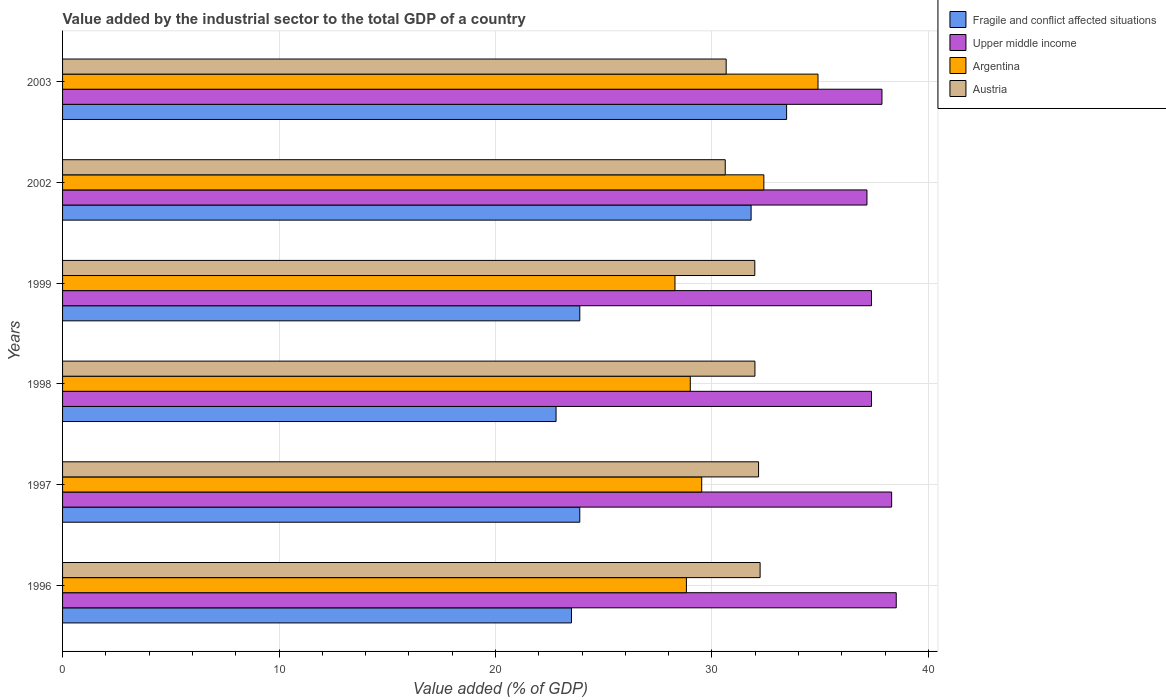How many groups of bars are there?
Offer a very short reply. 6. Are the number of bars per tick equal to the number of legend labels?
Your answer should be very brief. Yes. How many bars are there on the 4th tick from the top?
Give a very brief answer. 4. How many bars are there on the 2nd tick from the bottom?
Your answer should be very brief. 4. In how many cases, is the number of bars for a given year not equal to the number of legend labels?
Give a very brief answer. 0. What is the value added by the industrial sector to the total GDP in Austria in 1996?
Offer a terse response. 32.23. Across all years, what is the maximum value added by the industrial sector to the total GDP in Upper middle income?
Your answer should be compact. 38.52. Across all years, what is the minimum value added by the industrial sector to the total GDP in Austria?
Provide a short and direct response. 30.62. In which year was the value added by the industrial sector to the total GDP in Austria maximum?
Your response must be concise. 1996. In which year was the value added by the industrial sector to the total GDP in Argentina minimum?
Your answer should be very brief. 1999. What is the total value added by the industrial sector to the total GDP in Fragile and conflict affected situations in the graph?
Give a very brief answer. 159.37. What is the difference between the value added by the industrial sector to the total GDP in Fragile and conflict affected situations in 1997 and that in 2003?
Provide a succinct answer. -9.56. What is the difference between the value added by the industrial sector to the total GDP in Upper middle income in 1996 and the value added by the industrial sector to the total GDP in Austria in 1999?
Make the answer very short. 6.54. What is the average value added by the industrial sector to the total GDP in Austria per year?
Your answer should be very brief. 31.6. In the year 2003, what is the difference between the value added by the industrial sector to the total GDP in Fragile and conflict affected situations and value added by the industrial sector to the total GDP in Argentina?
Keep it short and to the point. -1.45. What is the ratio of the value added by the industrial sector to the total GDP in Upper middle income in 1997 to that in 1998?
Provide a succinct answer. 1.02. Is the value added by the industrial sector to the total GDP in Argentina in 1997 less than that in 1998?
Your response must be concise. No. What is the difference between the highest and the second highest value added by the industrial sector to the total GDP in Upper middle income?
Keep it short and to the point. 0.21. What is the difference between the highest and the lowest value added by the industrial sector to the total GDP in Fragile and conflict affected situations?
Provide a succinct answer. 10.65. In how many years, is the value added by the industrial sector to the total GDP in Fragile and conflict affected situations greater than the average value added by the industrial sector to the total GDP in Fragile and conflict affected situations taken over all years?
Your response must be concise. 2. Is the sum of the value added by the industrial sector to the total GDP in Fragile and conflict affected situations in 1997 and 2002 greater than the maximum value added by the industrial sector to the total GDP in Upper middle income across all years?
Provide a succinct answer. Yes. Is it the case that in every year, the sum of the value added by the industrial sector to the total GDP in Fragile and conflict affected situations and value added by the industrial sector to the total GDP in Austria is greater than the sum of value added by the industrial sector to the total GDP in Argentina and value added by the industrial sector to the total GDP in Upper middle income?
Ensure brevity in your answer.  No. What does the 3rd bar from the top in 1996 represents?
Your answer should be very brief. Upper middle income. Is it the case that in every year, the sum of the value added by the industrial sector to the total GDP in Fragile and conflict affected situations and value added by the industrial sector to the total GDP in Austria is greater than the value added by the industrial sector to the total GDP in Argentina?
Provide a succinct answer. Yes. How many bars are there?
Your answer should be very brief. 24. Are all the bars in the graph horizontal?
Provide a short and direct response. Yes. What is the difference between two consecutive major ticks on the X-axis?
Your answer should be very brief. 10. How many legend labels are there?
Your answer should be very brief. 4. What is the title of the graph?
Offer a very short reply. Value added by the industrial sector to the total GDP of a country. What is the label or title of the X-axis?
Your answer should be very brief. Value added (% of GDP). What is the Value added (% of GDP) in Fragile and conflict affected situations in 1996?
Your answer should be compact. 23.51. What is the Value added (% of GDP) in Upper middle income in 1996?
Offer a very short reply. 38.52. What is the Value added (% of GDP) in Argentina in 1996?
Keep it short and to the point. 28.82. What is the Value added (% of GDP) in Austria in 1996?
Your answer should be very brief. 32.23. What is the Value added (% of GDP) in Fragile and conflict affected situations in 1997?
Provide a short and direct response. 23.9. What is the Value added (% of GDP) in Upper middle income in 1997?
Ensure brevity in your answer.  38.3. What is the Value added (% of GDP) in Argentina in 1997?
Give a very brief answer. 29.53. What is the Value added (% of GDP) of Austria in 1997?
Provide a short and direct response. 32.16. What is the Value added (% of GDP) of Fragile and conflict affected situations in 1998?
Offer a very short reply. 22.8. What is the Value added (% of GDP) of Upper middle income in 1998?
Keep it short and to the point. 37.37. What is the Value added (% of GDP) of Argentina in 1998?
Ensure brevity in your answer.  29. What is the Value added (% of GDP) of Austria in 1998?
Keep it short and to the point. 31.99. What is the Value added (% of GDP) in Fragile and conflict affected situations in 1999?
Offer a terse response. 23.9. What is the Value added (% of GDP) of Upper middle income in 1999?
Make the answer very short. 37.37. What is the Value added (% of GDP) of Argentina in 1999?
Provide a short and direct response. 28.29. What is the Value added (% of GDP) of Austria in 1999?
Make the answer very short. 31.98. What is the Value added (% of GDP) in Fragile and conflict affected situations in 2002?
Offer a terse response. 31.81. What is the Value added (% of GDP) of Upper middle income in 2002?
Your answer should be compact. 37.16. What is the Value added (% of GDP) in Argentina in 2002?
Your answer should be very brief. 32.4. What is the Value added (% of GDP) in Austria in 2002?
Your answer should be compact. 30.62. What is the Value added (% of GDP) of Fragile and conflict affected situations in 2003?
Your answer should be very brief. 33.45. What is the Value added (% of GDP) of Upper middle income in 2003?
Give a very brief answer. 37.86. What is the Value added (% of GDP) of Argentina in 2003?
Your response must be concise. 34.9. What is the Value added (% of GDP) in Austria in 2003?
Your answer should be very brief. 30.66. Across all years, what is the maximum Value added (% of GDP) in Fragile and conflict affected situations?
Make the answer very short. 33.45. Across all years, what is the maximum Value added (% of GDP) in Upper middle income?
Offer a very short reply. 38.52. Across all years, what is the maximum Value added (% of GDP) in Argentina?
Your answer should be very brief. 34.9. Across all years, what is the maximum Value added (% of GDP) in Austria?
Make the answer very short. 32.23. Across all years, what is the minimum Value added (% of GDP) in Fragile and conflict affected situations?
Your answer should be very brief. 22.8. Across all years, what is the minimum Value added (% of GDP) in Upper middle income?
Offer a terse response. 37.16. Across all years, what is the minimum Value added (% of GDP) of Argentina?
Provide a short and direct response. 28.29. Across all years, what is the minimum Value added (% of GDP) in Austria?
Your answer should be compact. 30.62. What is the total Value added (% of GDP) of Fragile and conflict affected situations in the graph?
Your answer should be very brief. 159.37. What is the total Value added (% of GDP) in Upper middle income in the graph?
Make the answer very short. 226.59. What is the total Value added (% of GDP) in Argentina in the graph?
Make the answer very short. 182.95. What is the total Value added (% of GDP) of Austria in the graph?
Offer a very short reply. 189.63. What is the difference between the Value added (% of GDP) of Fragile and conflict affected situations in 1996 and that in 1997?
Offer a terse response. -0.38. What is the difference between the Value added (% of GDP) of Upper middle income in 1996 and that in 1997?
Your response must be concise. 0.21. What is the difference between the Value added (% of GDP) in Argentina in 1996 and that in 1997?
Give a very brief answer. -0.71. What is the difference between the Value added (% of GDP) in Austria in 1996 and that in 1997?
Offer a very short reply. 0.07. What is the difference between the Value added (% of GDP) of Fragile and conflict affected situations in 1996 and that in 1998?
Your response must be concise. 0.71. What is the difference between the Value added (% of GDP) of Upper middle income in 1996 and that in 1998?
Offer a terse response. 1.14. What is the difference between the Value added (% of GDP) in Argentina in 1996 and that in 1998?
Your answer should be very brief. -0.18. What is the difference between the Value added (% of GDP) in Austria in 1996 and that in 1998?
Offer a very short reply. 0.24. What is the difference between the Value added (% of GDP) of Fragile and conflict affected situations in 1996 and that in 1999?
Provide a succinct answer. -0.39. What is the difference between the Value added (% of GDP) in Upper middle income in 1996 and that in 1999?
Your answer should be compact. 1.14. What is the difference between the Value added (% of GDP) of Argentina in 1996 and that in 1999?
Provide a succinct answer. 0.53. What is the difference between the Value added (% of GDP) in Austria in 1996 and that in 1999?
Make the answer very short. 0.25. What is the difference between the Value added (% of GDP) of Fragile and conflict affected situations in 1996 and that in 2002?
Keep it short and to the point. -8.3. What is the difference between the Value added (% of GDP) of Upper middle income in 1996 and that in 2002?
Offer a very short reply. 1.35. What is the difference between the Value added (% of GDP) of Argentina in 1996 and that in 2002?
Offer a very short reply. -3.58. What is the difference between the Value added (% of GDP) of Austria in 1996 and that in 2002?
Ensure brevity in your answer.  1.61. What is the difference between the Value added (% of GDP) in Fragile and conflict affected situations in 1996 and that in 2003?
Your answer should be very brief. -9.94. What is the difference between the Value added (% of GDP) of Upper middle income in 1996 and that in 2003?
Give a very brief answer. 0.66. What is the difference between the Value added (% of GDP) in Argentina in 1996 and that in 2003?
Your answer should be compact. -6.08. What is the difference between the Value added (% of GDP) of Austria in 1996 and that in 2003?
Your answer should be compact. 1.57. What is the difference between the Value added (% of GDP) in Fragile and conflict affected situations in 1997 and that in 1998?
Keep it short and to the point. 1.1. What is the difference between the Value added (% of GDP) in Upper middle income in 1997 and that in 1998?
Keep it short and to the point. 0.93. What is the difference between the Value added (% of GDP) in Argentina in 1997 and that in 1998?
Ensure brevity in your answer.  0.53. What is the difference between the Value added (% of GDP) of Austria in 1997 and that in 1998?
Offer a terse response. 0.17. What is the difference between the Value added (% of GDP) of Fragile and conflict affected situations in 1997 and that in 1999?
Your answer should be very brief. -0. What is the difference between the Value added (% of GDP) in Upper middle income in 1997 and that in 1999?
Make the answer very short. 0.93. What is the difference between the Value added (% of GDP) in Argentina in 1997 and that in 1999?
Your answer should be very brief. 1.23. What is the difference between the Value added (% of GDP) of Austria in 1997 and that in 1999?
Keep it short and to the point. 0.17. What is the difference between the Value added (% of GDP) of Fragile and conflict affected situations in 1997 and that in 2002?
Ensure brevity in your answer.  -7.92. What is the difference between the Value added (% of GDP) in Upper middle income in 1997 and that in 2002?
Your answer should be compact. 1.14. What is the difference between the Value added (% of GDP) of Argentina in 1997 and that in 2002?
Provide a short and direct response. -2.87. What is the difference between the Value added (% of GDP) in Austria in 1997 and that in 2002?
Keep it short and to the point. 1.54. What is the difference between the Value added (% of GDP) of Fragile and conflict affected situations in 1997 and that in 2003?
Keep it short and to the point. -9.56. What is the difference between the Value added (% of GDP) in Upper middle income in 1997 and that in 2003?
Provide a succinct answer. 0.45. What is the difference between the Value added (% of GDP) of Argentina in 1997 and that in 2003?
Offer a terse response. -5.37. What is the difference between the Value added (% of GDP) of Austria in 1997 and that in 2003?
Your answer should be compact. 1.5. What is the difference between the Value added (% of GDP) in Fragile and conflict affected situations in 1998 and that in 1999?
Offer a very short reply. -1.1. What is the difference between the Value added (% of GDP) in Upper middle income in 1998 and that in 1999?
Ensure brevity in your answer.  -0. What is the difference between the Value added (% of GDP) in Argentina in 1998 and that in 1999?
Give a very brief answer. 0.71. What is the difference between the Value added (% of GDP) in Austria in 1998 and that in 1999?
Your response must be concise. 0.01. What is the difference between the Value added (% of GDP) of Fragile and conflict affected situations in 1998 and that in 2002?
Offer a very short reply. -9.01. What is the difference between the Value added (% of GDP) of Upper middle income in 1998 and that in 2002?
Give a very brief answer. 0.21. What is the difference between the Value added (% of GDP) of Argentina in 1998 and that in 2002?
Give a very brief answer. -3.4. What is the difference between the Value added (% of GDP) in Austria in 1998 and that in 2002?
Your response must be concise. 1.37. What is the difference between the Value added (% of GDP) of Fragile and conflict affected situations in 1998 and that in 2003?
Provide a short and direct response. -10.65. What is the difference between the Value added (% of GDP) in Upper middle income in 1998 and that in 2003?
Keep it short and to the point. -0.48. What is the difference between the Value added (% of GDP) of Argentina in 1998 and that in 2003?
Offer a terse response. -5.9. What is the difference between the Value added (% of GDP) in Austria in 1998 and that in 2003?
Provide a succinct answer. 1.33. What is the difference between the Value added (% of GDP) of Fragile and conflict affected situations in 1999 and that in 2002?
Offer a terse response. -7.91. What is the difference between the Value added (% of GDP) of Upper middle income in 1999 and that in 2002?
Ensure brevity in your answer.  0.21. What is the difference between the Value added (% of GDP) in Argentina in 1999 and that in 2002?
Ensure brevity in your answer.  -4.11. What is the difference between the Value added (% of GDP) of Austria in 1999 and that in 2002?
Provide a short and direct response. 1.37. What is the difference between the Value added (% of GDP) in Fragile and conflict affected situations in 1999 and that in 2003?
Keep it short and to the point. -9.55. What is the difference between the Value added (% of GDP) in Upper middle income in 1999 and that in 2003?
Your answer should be compact. -0.48. What is the difference between the Value added (% of GDP) of Argentina in 1999 and that in 2003?
Your answer should be very brief. -6.61. What is the difference between the Value added (% of GDP) of Austria in 1999 and that in 2003?
Offer a terse response. 1.32. What is the difference between the Value added (% of GDP) in Fragile and conflict affected situations in 2002 and that in 2003?
Provide a short and direct response. -1.64. What is the difference between the Value added (% of GDP) of Upper middle income in 2002 and that in 2003?
Offer a terse response. -0.69. What is the difference between the Value added (% of GDP) of Argentina in 2002 and that in 2003?
Provide a short and direct response. -2.5. What is the difference between the Value added (% of GDP) of Austria in 2002 and that in 2003?
Ensure brevity in your answer.  -0.04. What is the difference between the Value added (% of GDP) of Fragile and conflict affected situations in 1996 and the Value added (% of GDP) of Upper middle income in 1997?
Make the answer very short. -14.79. What is the difference between the Value added (% of GDP) in Fragile and conflict affected situations in 1996 and the Value added (% of GDP) in Argentina in 1997?
Your response must be concise. -6.02. What is the difference between the Value added (% of GDP) in Fragile and conflict affected situations in 1996 and the Value added (% of GDP) in Austria in 1997?
Your response must be concise. -8.64. What is the difference between the Value added (% of GDP) in Upper middle income in 1996 and the Value added (% of GDP) in Argentina in 1997?
Provide a succinct answer. 8.99. What is the difference between the Value added (% of GDP) of Upper middle income in 1996 and the Value added (% of GDP) of Austria in 1997?
Offer a very short reply. 6.36. What is the difference between the Value added (% of GDP) in Argentina in 1996 and the Value added (% of GDP) in Austria in 1997?
Keep it short and to the point. -3.33. What is the difference between the Value added (% of GDP) of Fragile and conflict affected situations in 1996 and the Value added (% of GDP) of Upper middle income in 1998?
Provide a succinct answer. -13.86. What is the difference between the Value added (% of GDP) in Fragile and conflict affected situations in 1996 and the Value added (% of GDP) in Argentina in 1998?
Your response must be concise. -5.49. What is the difference between the Value added (% of GDP) in Fragile and conflict affected situations in 1996 and the Value added (% of GDP) in Austria in 1998?
Offer a terse response. -8.48. What is the difference between the Value added (% of GDP) in Upper middle income in 1996 and the Value added (% of GDP) in Argentina in 1998?
Provide a succinct answer. 9.52. What is the difference between the Value added (% of GDP) in Upper middle income in 1996 and the Value added (% of GDP) in Austria in 1998?
Offer a terse response. 6.53. What is the difference between the Value added (% of GDP) of Argentina in 1996 and the Value added (% of GDP) of Austria in 1998?
Make the answer very short. -3.17. What is the difference between the Value added (% of GDP) in Fragile and conflict affected situations in 1996 and the Value added (% of GDP) in Upper middle income in 1999?
Your answer should be compact. -13.86. What is the difference between the Value added (% of GDP) of Fragile and conflict affected situations in 1996 and the Value added (% of GDP) of Argentina in 1999?
Offer a terse response. -4.78. What is the difference between the Value added (% of GDP) in Fragile and conflict affected situations in 1996 and the Value added (% of GDP) in Austria in 1999?
Give a very brief answer. -8.47. What is the difference between the Value added (% of GDP) in Upper middle income in 1996 and the Value added (% of GDP) in Argentina in 1999?
Your answer should be very brief. 10.22. What is the difference between the Value added (% of GDP) of Upper middle income in 1996 and the Value added (% of GDP) of Austria in 1999?
Make the answer very short. 6.54. What is the difference between the Value added (% of GDP) in Argentina in 1996 and the Value added (% of GDP) in Austria in 1999?
Provide a succinct answer. -3.16. What is the difference between the Value added (% of GDP) of Fragile and conflict affected situations in 1996 and the Value added (% of GDP) of Upper middle income in 2002?
Make the answer very short. -13.65. What is the difference between the Value added (% of GDP) of Fragile and conflict affected situations in 1996 and the Value added (% of GDP) of Argentina in 2002?
Your answer should be compact. -8.89. What is the difference between the Value added (% of GDP) of Fragile and conflict affected situations in 1996 and the Value added (% of GDP) of Austria in 2002?
Your response must be concise. -7.1. What is the difference between the Value added (% of GDP) of Upper middle income in 1996 and the Value added (% of GDP) of Argentina in 2002?
Give a very brief answer. 6.12. What is the difference between the Value added (% of GDP) in Upper middle income in 1996 and the Value added (% of GDP) in Austria in 2002?
Keep it short and to the point. 7.9. What is the difference between the Value added (% of GDP) of Argentina in 1996 and the Value added (% of GDP) of Austria in 2002?
Your answer should be very brief. -1.79. What is the difference between the Value added (% of GDP) of Fragile and conflict affected situations in 1996 and the Value added (% of GDP) of Upper middle income in 2003?
Your response must be concise. -14.35. What is the difference between the Value added (% of GDP) of Fragile and conflict affected situations in 1996 and the Value added (% of GDP) of Argentina in 2003?
Ensure brevity in your answer.  -11.39. What is the difference between the Value added (% of GDP) of Fragile and conflict affected situations in 1996 and the Value added (% of GDP) of Austria in 2003?
Offer a very short reply. -7.15. What is the difference between the Value added (% of GDP) of Upper middle income in 1996 and the Value added (% of GDP) of Argentina in 2003?
Make the answer very short. 3.61. What is the difference between the Value added (% of GDP) in Upper middle income in 1996 and the Value added (% of GDP) in Austria in 2003?
Provide a short and direct response. 7.86. What is the difference between the Value added (% of GDP) of Argentina in 1996 and the Value added (% of GDP) of Austria in 2003?
Offer a very short reply. -1.84. What is the difference between the Value added (% of GDP) in Fragile and conflict affected situations in 1997 and the Value added (% of GDP) in Upper middle income in 1998?
Provide a succinct answer. -13.48. What is the difference between the Value added (% of GDP) in Fragile and conflict affected situations in 1997 and the Value added (% of GDP) in Argentina in 1998?
Provide a short and direct response. -5.11. What is the difference between the Value added (% of GDP) of Fragile and conflict affected situations in 1997 and the Value added (% of GDP) of Austria in 1998?
Your answer should be very brief. -8.09. What is the difference between the Value added (% of GDP) of Upper middle income in 1997 and the Value added (% of GDP) of Argentina in 1998?
Keep it short and to the point. 9.3. What is the difference between the Value added (% of GDP) in Upper middle income in 1997 and the Value added (% of GDP) in Austria in 1998?
Your answer should be very brief. 6.32. What is the difference between the Value added (% of GDP) of Argentina in 1997 and the Value added (% of GDP) of Austria in 1998?
Your answer should be very brief. -2.46. What is the difference between the Value added (% of GDP) in Fragile and conflict affected situations in 1997 and the Value added (% of GDP) in Upper middle income in 1999?
Give a very brief answer. -13.48. What is the difference between the Value added (% of GDP) in Fragile and conflict affected situations in 1997 and the Value added (% of GDP) in Argentina in 1999?
Keep it short and to the point. -4.4. What is the difference between the Value added (% of GDP) of Fragile and conflict affected situations in 1997 and the Value added (% of GDP) of Austria in 1999?
Your response must be concise. -8.09. What is the difference between the Value added (% of GDP) in Upper middle income in 1997 and the Value added (% of GDP) in Argentina in 1999?
Make the answer very short. 10.01. What is the difference between the Value added (% of GDP) of Upper middle income in 1997 and the Value added (% of GDP) of Austria in 1999?
Offer a terse response. 6.32. What is the difference between the Value added (% of GDP) in Argentina in 1997 and the Value added (% of GDP) in Austria in 1999?
Provide a short and direct response. -2.45. What is the difference between the Value added (% of GDP) in Fragile and conflict affected situations in 1997 and the Value added (% of GDP) in Upper middle income in 2002?
Provide a short and direct response. -13.27. What is the difference between the Value added (% of GDP) in Fragile and conflict affected situations in 1997 and the Value added (% of GDP) in Argentina in 2002?
Your response must be concise. -8.5. What is the difference between the Value added (% of GDP) of Fragile and conflict affected situations in 1997 and the Value added (% of GDP) of Austria in 2002?
Your answer should be compact. -6.72. What is the difference between the Value added (% of GDP) of Upper middle income in 1997 and the Value added (% of GDP) of Argentina in 2002?
Make the answer very short. 5.9. What is the difference between the Value added (% of GDP) of Upper middle income in 1997 and the Value added (% of GDP) of Austria in 2002?
Your answer should be compact. 7.69. What is the difference between the Value added (% of GDP) of Argentina in 1997 and the Value added (% of GDP) of Austria in 2002?
Keep it short and to the point. -1.09. What is the difference between the Value added (% of GDP) of Fragile and conflict affected situations in 1997 and the Value added (% of GDP) of Upper middle income in 2003?
Your answer should be compact. -13.96. What is the difference between the Value added (% of GDP) of Fragile and conflict affected situations in 1997 and the Value added (% of GDP) of Argentina in 2003?
Ensure brevity in your answer.  -11.01. What is the difference between the Value added (% of GDP) in Fragile and conflict affected situations in 1997 and the Value added (% of GDP) in Austria in 2003?
Offer a very short reply. -6.76. What is the difference between the Value added (% of GDP) of Upper middle income in 1997 and the Value added (% of GDP) of Argentina in 2003?
Offer a very short reply. 3.4. What is the difference between the Value added (% of GDP) of Upper middle income in 1997 and the Value added (% of GDP) of Austria in 2003?
Offer a terse response. 7.64. What is the difference between the Value added (% of GDP) in Argentina in 1997 and the Value added (% of GDP) in Austria in 2003?
Give a very brief answer. -1.13. What is the difference between the Value added (% of GDP) of Fragile and conflict affected situations in 1998 and the Value added (% of GDP) of Upper middle income in 1999?
Your answer should be compact. -14.57. What is the difference between the Value added (% of GDP) in Fragile and conflict affected situations in 1998 and the Value added (% of GDP) in Argentina in 1999?
Your answer should be compact. -5.49. What is the difference between the Value added (% of GDP) of Fragile and conflict affected situations in 1998 and the Value added (% of GDP) of Austria in 1999?
Provide a short and direct response. -9.18. What is the difference between the Value added (% of GDP) in Upper middle income in 1998 and the Value added (% of GDP) in Argentina in 1999?
Your answer should be compact. 9.08. What is the difference between the Value added (% of GDP) of Upper middle income in 1998 and the Value added (% of GDP) of Austria in 1999?
Offer a very short reply. 5.39. What is the difference between the Value added (% of GDP) in Argentina in 1998 and the Value added (% of GDP) in Austria in 1999?
Your answer should be compact. -2.98. What is the difference between the Value added (% of GDP) in Fragile and conflict affected situations in 1998 and the Value added (% of GDP) in Upper middle income in 2002?
Provide a short and direct response. -14.36. What is the difference between the Value added (% of GDP) in Fragile and conflict affected situations in 1998 and the Value added (% of GDP) in Argentina in 2002?
Your answer should be compact. -9.6. What is the difference between the Value added (% of GDP) of Fragile and conflict affected situations in 1998 and the Value added (% of GDP) of Austria in 2002?
Give a very brief answer. -7.82. What is the difference between the Value added (% of GDP) of Upper middle income in 1998 and the Value added (% of GDP) of Argentina in 2002?
Keep it short and to the point. 4.97. What is the difference between the Value added (% of GDP) of Upper middle income in 1998 and the Value added (% of GDP) of Austria in 2002?
Your answer should be very brief. 6.76. What is the difference between the Value added (% of GDP) in Argentina in 1998 and the Value added (% of GDP) in Austria in 2002?
Ensure brevity in your answer.  -1.61. What is the difference between the Value added (% of GDP) of Fragile and conflict affected situations in 1998 and the Value added (% of GDP) of Upper middle income in 2003?
Give a very brief answer. -15.06. What is the difference between the Value added (% of GDP) in Fragile and conflict affected situations in 1998 and the Value added (% of GDP) in Argentina in 2003?
Provide a short and direct response. -12.1. What is the difference between the Value added (% of GDP) in Fragile and conflict affected situations in 1998 and the Value added (% of GDP) in Austria in 2003?
Make the answer very short. -7.86. What is the difference between the Value added (% of GDP) in Upper middle income in 1998 and the Value added (% of GDP) in Argentina in 2003?
Make the answer very short. 2.47. What is the difference between the Value added (% of GDP) of Upper middle income in 1998 and the Value added (% of GDP) of Austria in 2003?
Provide a short and direct response. 6.71. What is the difference between the Value added (% of GDP) of Argentina in 1998 and the Value added (% of GDP) of Austria in 2003?
Make the answer very short. -1.66. What is the difference between the Value added (% of GDP) of Fragile and conflict affected situations in 1999 and the Value added (% of GDP) of Upper middle income in 2002?
Your response must be concise. -13.27. What is the difference between the Value added (% of GDP) of Fragile and conflict affected situations in 1999 and the Value added (% of GDP) of Argentina in 2002?
Your answer should be compact. -8.5. What is the difference between the Value added (% of GDP) in Fragile and conflict affected situations in 1999 and the Value added (% of GDP) in Austria in 2002?
Offer a very short reply. -6.72. What is the difference between the Value added (% of GDP) in Upper middle income in 1999 and the Value added (% of GDP) in Argentina in 2002?
Offer a very short reply. 4.97. What is the difference between the Value added (% of GDP) of Upper middle income in 1999 and the Value added (% of GDP) of Austria in 2002?
Your answer should be very brief. 6.76. What is the difference between the Value added (% of GDP) in Argentina in 1999 and the Value added (% of GDP) in Austria in 2002?
Your answer should be compact. -2.32. What is the difference between the Value added (% of GDP) in Fragile and conflict affected situations in 1999 and the Value added (% of GDP) in Upper middle income in 2003?
Offer a very short reply. -13.96. What is the difference between the Value added (% of GDP) of Fragile and conflict affected situations in 1999 and the Value added (% of GDP) of Argentina in 2003?
Offer a very short reply. -11.01. What is the difference between the Value added (% of GDP) in Fragile and conflict affected situations in 1999 and the Value added (% of GDP) in Austria in 2003?
Offer a very short reply. -6.76. What is the difference between the Value added (% of GDP) of Upper middle income in 1999 and the Value added (% of GDP) of Argentina in 2003?
Provide a short and direct response. 2.47. What is the difference between the Value added (% of GDP) in Upper middle income in 1999 and the Value added (% of GDP) in Austria in 2003?
Give a very brief answer. 6.71. What is the difference between the Value added (% of GDP) in Argentina in 1999 and the Value added (% of GDP) in Austria in 2003?
Ensure brevity in your answer.  -2.37. What is the difference between the Value added (% of GDP) in Fragile and conflict affected situations in 2002 and the Value added (% of GDP) in Upper middle income in 2003?
Your response must be concise. -6.05. What is the difference between the Value added (% of GDP) of Fragile and conflict affected situations in 2002 and the Value added (% of GDP) of Argentina in 2003?
Give a very brief answer. -3.09. What is the difference between the Value added (% of GDP) in Fragile and conflict affected situations in 2002 and the Value added (% of GDP) in Austria in 2003?
Your answer should be very brief. 1.15. What is the difference between the Value added (% of GDP) of Upper middle income in 2002 and the Value added (% of GDP) of Argentina in 2003?
Provide a succinct answer. 2.26. What is the difference between the Value added (% of GDP) of Upper middle income in 2002 and the Value added (% of GDP) of Austria in 2003?
Ensure brevity in your answer.  6.5. What is the difference between the Value added (% of GDP) of Argentina in 2002 and the Value added (% of GDP) of Austria in 2003?
Ensure brevity in your answer.  1.74. What is the average Value added (% of GDP) in Fragile and conflict affected situations per year?
Keep it short and to the point. 26.56. What is the average Value added (% of GDP) in Upper middle income per year?
Provide a short and direct response. 37.76. What is the average Value added (% of GDP) in Argentina per year?
Ensure brevity in your answer.  30.49. What is the average Value added (% of GDP) in Austria per year?
Your answer should be very brief. 31.6. In the year 1996, what is the difference between the Value added (% of GDP) in Fragile and conflict affected situations and Value added (% of GDP) in Upper middle income?
Your answer should be compact. -15.01. In the year 1996, what is the difference between the Value added (% of GDP) in Fragile and conflict affected situations and Value added (% of GDP) in Argentina?
Your answer should be compact. -5.31. In the year 1996, what is the difference between the Value added (% of GDP) of Fragile and conflict affected situations and Value added (% of GDP) of Austria?
Your answer should be compact. -8.72. In the year 1996, what is the difference between the Value added (% of GDP) of Upper middle income and Value added (% of GDP) of Argentina?
Your response must be concise. 9.7. In the year 1996, what is the difference between the Value added (% of GDP) in Upper middle income and Value added (% of GDP) in Austria?
Keep it short and to the point. 6.29. In the year 1996, what is the difference between the Value added (% of GDP) in Argentina and Value added (% of GDP) in Austria?
Offer a terse response. -3.41. In the year 1997, what is the difference between the Value added (% of GDP) in Fragile and conflict affected situations and Value added (% of GDP) in Upper middle income?
Offer a very short reply. -14.41. In the year 1997, what is the difference between the Value added (% of GDP) of Fragile and conflict affected situations and Value added (% of GDP) of Argentina?
Offer a very short reply. -5.63. In the year 1997, what is the difference between the Value added (% of GDP) in Fragile and conflict affected situations and Value added (% of GDP) in Austria?
Your answer should be compact. -8.26. In the year 1997, what is the difference between the Value added (% of GDP) of Upper middle income and Value added (% of GDP) of Argentina?
Provide a succinct answer. 8.78. In the year 1997, what is the difference between the Value added (% of GDP) of Upper middle income and Value added (% of GDP) of Austria?
Keep it short and to the point. 6.15. In the year 1997, what is the difference between the Value added (% of GDP) in Argentina and Value added (% of GDP) in Austria?
Offer a terse response. -2.63. In the year 1998, what is the difference between the Value added (% of GDP) of Fragile and conflict affected situations and Value added (% of GDP) of Upper middle income?
Provide a short and direct response. -14.57. In the year 1998, what is the difference between the Value added (% of GDP) in Fragile and conflict affected situations and Value added (% of GDP) in Argentina?
Make the answer very short. -6.2. In the year 1998, what is the difference between the Value added (% of GDP) of Fragile and conflict affected situations and Value added (% of GDP) of Austria?
Provide a succinct answer. -9.19. In the year 1998, what is the difference between the Value added (% of GDP) of Upper middle income and Value added (% of GDP) of Argentina?
Your response must be concise. 8.37. In the year 1998, what is the difference between the Value added (% of GDP) of Upper middle income and Value added (% of GDP) of Austria?
Your answer should be compact. 5.38. In the year 1998, what is the difference between the Value added (% of GDP) in Argentina and Value added (% of GDP) in Austria?
Make the answer very short. -2.99. In the year 1999, what is the difference between the Value added (% of GDP) in Fragile and conflict affected situations and Value added (% of GDP) in Upper middle income?
Give a very brief answer. -13.48. In the year 1999, what is the difference between the Value added (% of GDP) in Fragile and conflict affected situations and Value added (% of GDP) in Argentina?
Your answer should be very brief. -4.4. In the year 1999, what is the difference between the Value added (% of GDP) of Fragile and conflict affected situations and Value added (% of GDP) of Austria?
Offer a terse response. -8.08. In the year 1999, what is the difference between the Value added (% of GDP) in Upper middle income and Value added (% of GDP) in Argentina?
Provide a succinct answer. 9.08. In the year 1999, what is the difference between the Value added (% of GDP) in Upper middle income and Value added (% of GDP) in Austria?
Offer a very short reply. 5.39. In the year 1999, what is the difference between the Value added (% of GDP) in Argentina and Value added (% of GDP) in Austria?
Your answer should be very brief. -3.69. In the year 2002, what is the difference between the Value added (% of GDP) in Fragile and conflict affected situations and Value added (% of GDP) in Upper middle income?
Give a very brief answer. -5.35. In the year 2002, what is the difference between the Value added (% of GDP) of Fragile and conflict affected situations and Value added (% of GDP) of Argentina?
Provide a succinct answer. -0.59. In the year 2002, what is the difference between the Value added (% of GDP) in Fragile and conflict affected situations and Value added (% of GDP) in Austria?
Provide a succinct answer. 1.2. In the year 2002, what is the difference between the Value added (% of GDP) in Upper middle income and Value added (% of GDP) in Argentina?
Keep it short and to the point. 4.76. In the year 2002, what is the difference between the Value added (% of GDP) in Upper middle income and Value added (% of GDP) in Austria?
Offer a terse response. 6.55. In the year 2002, what is the difference between the Value added (% of GDP) of Argentina and Value added (% of GDP) of Austria?
Your response must be concise. 1.78. In the year 2003, what is the difference between the Value added (% of GDP) in Fragile and conflict affected situations and Value added (% of GDP) in Upper middle income?
Ensure brevity in your answer.  -4.41. In the year 2003, what is the difference between the Value added (% of GDP) of Fragile and conflict affected situations and Value added (% of GDP) of Argentina?
Provide a short and direct response. -1.45. In the year 2003, what is the difference between the Value added (% of GDP) in Fragile and conflict affected situations and Value added (% of GDP) in Austria?
Ensure brevity in your answer.  2.79. In the year 2003, what is the difference between the Value added (% of GDP) in Upper middle income and Value added (% of GDP) in Argentina?
Offer a terse response. 2.96. In the year 2003, what is the difference between the Value added (% of GDP) of Upper middle income and Value added (% of GDP) of Austria?
Offer a terse response. 7.2. In the year 2003, what is the difference between the Value added (% of GDP) in Argentina and Value added (% of GDP) in Austria?
Make the answer very short. 4.24. What is the ratio of the Value added (% of GDP) in Fragile and conflict affected situations in 1996 to that in 1997?
Your answer should be compact. 0.98. What is the ratio of the Value added (% of GDP) of Upper middle income in 1996 to that in 1997?
Your response must be concise. 1.01. What is the ratio of the Value added (% of GDP) in Argentina in 1996 to that in 1997?
Keep it short and to the point. 0.98. What is the ratio of the Value added (% of GDP) in Austria in 1996 to that in 1997?
Ensure brevity in your answer.  1. What is the ratio of the Value added (% of GDP) in Fragile and conflict affected situations in 1996 to that in 1998?
Offer a terse response. 1.03. What is the ratio of the Value added (% of GDP) in Upper middle income in 1996 to that in 1998?
Your response must be concise. 1.03. What is the ratio of the Value added (% of GDP) in Austria in 1996 to that in 1998?
Give a very brief answer. 1.01. What is the ratio of the Value added (% of GDP) in Fragile and conflict affected situations in 1996 to that in 1999?
Provide a succinct answer. 0.98. What is the ratio of the Value added (% of GDP) in Upper middle income in 1996 to that in 1999?
Offer a terse response. 1.03. What is the ratio of the Value added (% of GDP) of Argentina in 1996 to that in 1999?
Your answer should be compact. 1.02. What is the ratio of the Value added (% of GDP) of Austria in 1996 to that in 1999?
Offer a terse response. 1.01. What is the ratio of the Value added (% of GDP) in Fragile and conflict affected situations in 1996 to that in 2002?
Your response must be concise. 0.74. What is the ratio of the Value added (% of GDP) in Upper middle income in 1996 to that in 2002?
Your answer should be very brief. 1.04. What is the ratio of the Value added (% of GDP) of Argentina in 1996 to that in 2002?
Your answer should be very brief. 0.89. What is the ratio of the Value added (% of GDP) of Austria in 1996 to that in 2002?
Your answer should be very brief. 1.05. What is the ratio of the Value added (% of GDP) of Fragile and conflict affected situations in 1996 to that in 2003?
Offer a very short reply. 0.7. What is the ratio of the Value added (% of GDP) in Upper middle income in 1996 to that in 2003?
Your answer should be very brief. 1.02. What is the ratio of the Value added (% of GDP) in Argentina in 1996 to that in 2003?
Your answer should be compact. 0.83. What is the ratio of the Value added (% of GDP) in Austria in 1996 to that in 2003?
Keep it short and to the point. 1.05. What is the ratio of the Value added (% of GDP) of Fragile and conflict affected situations in 1997 to that in 1998?
Keep it short and to the point. 1.05. What is the ratio of the Value added (% of GDP) of Upper middle income in 1997 to that in 1998?
Your answer should be compact. 1.02. What is the ratio of the Value added (% of GDP) in Argentina in 1997 to that in 1998?
Ensure brevity in your answer.  1.02. What is the ratio of the Value added (% of GDP) of Upper middle income in 1997 to that in 1999?
Your answer should be compact. 1.02. What is the ratio of the Value added (% of GDP) of Argentina in 1997 to that in 1999?
Keep it short and to the point. 1.04. What is the ratio of the Value added (% of GDP) of Austria in 1997 to that in 1999?
Ensure brevity in your answer.  1.01. What is the ratio of the Value added (% of GDP) of Fragile and conflict affected situations in 1997 to that in 2002?
Your answer should be very brief. 0.75. What is the ratio of the Value added (% of GDP) of Upper middle income in 1997 to that in 2002?
Your answer should be compact. 1.03. What is the ratio of the Value added (% of GDP) of Argentina in 1997 to that in 2002?
Offer a terse response. 0.91. What is the ratio of the Value added (% of GDP) of Austria in 1997 to that in 2002?
Provide a succinct answer. 1.05. What is the ratio of the Value added (% of GDP) of Upper middle income in 1997 to that in 2003?
Your answer should be very brief. 1.01. What is the ratio of the Value added (% of GDP) in Argentina in 1997 to that in 2003?
Your answer should be very brief. 0.85. What is the ratio of the Value added (% of GDP) in Austria in 1997 to that in 2003?
Your answer should be very brief. 1.05. What is the ratio of the Value added (% of GDP) of Fragile and conflict affected situations in 1998 to that in 1999?
Your answer should be very brief. 0.95. What is the ratio of the Value added (% of GDP) in Upper middle income in 1998 to that in 1999?
Make the answer very short. 1. What is the ratio of the Value added (% of GDP) of Argentina in 1998 to that in 1999?
Your answer should be compact. 1.02. What is the ratio of the Value added (% of GDP) in Fragile and conflict affected situations in 1998 to that in 2002?
Offer a terse response. 0.72. What is the ratio of the Value added (% of GDP) of Upper middle income in 1998 to that in 2002?
Make the answer very short. 1.01. What is the ratio of the Value added (% of GDP) of Argentina in 1998 to that in 2002?
Your answer should be very brief. 0.9. What is the ratio of the Value added (% of GDP) of Austria in 1998 to that in 2002?
Your answer should be very brief. 1.04. What is the ratio of the Value added (% of GDP) in Fragile and conflict affected situations in 1998 to that in 2003?
Ensure brevity in your answer.  0.68. What is the ratio of the Value added (% of GDP) of Upper middle income in 1998 to that in 2003?
Keep it short and to the point. 0.99. What is the ratio of the Value added (% of GDP) of Argentina in 1998 to that in 2003?
Give a very brief answer. 0.83. What is the ratio of the Value added (% of GDP) of Austria in 1998 to that in 2003?
Provide a short and direct response. 1.04. What is the ratio of the Value added (% of GDP) of Fragile and conflict affected situations in 1999 to that in 2002?
Offer a terse response. 0.75. What is the ratio of the Value added (% of GDP) in Upper middle income in 1999 to that in 2002?
Give a very brief answer. 1.01. What is the ratio of the Value added (% of GDP) of Argentina in 1999 to that in 2002?
Make the answer very short. 0.87. What is the ratio of the Value added (% of GDP) in Austria in 1999 to that in 2002?
Your answer should be compact. 1.04. What is the ratio of the Value added (% of GDP) of Fragile and conflict affected situations in 1999 to that in 2003?
Offer a terse response. 0.71. What is the ratio of the Value added (% of GDP) of Upper middle income in 1999 to that in 2003?
Provide a short and direct response. 0.99. What is the ratio of the Value added (% of GDP) in Argentina in 1999 to that in 2003?
Your answer should be very brief. 0.81. What is the ratio of the Value added (% of GDP) of Austria in 1999 to that in 2003?
Your answer should be very brief. 1.04. What is the ratio of the Value added (% of GDP) in Fragile and conflict affected situations in 2002 to that in 2003?
Offer a very short reply. 0.95. What is the ratio of the Value added (% of GDP) of Upper middle income in 2002 to that in 2003?
Offer a terse response. 0.98. What is the ratio of the Value added (% of GDP) of Argentina in 2002 to that in 2003?
Your answer should be very brief. 0.93. What is the ratio of the Value added (% of GDP) in Austria in 2002 to that in 2003?
Offer a very short reply. 1. What is the difference between the highest and the second highest Value added (% of GDP) of Fragile and conflict affected situations?
Your answer should be very brief. 1.64. What is the difference between the highest and the second highest Value added (% of GDP) in Upper middle income?
Provide a succinct answer. 0.21. What is the difference between the highest and the second highest Value added (% of GDP) in Argentina?
Offer a very short reply. 2.5. What is the difference between the highest and the second highest Value added (% of GDP) of Austria?
Provide a short and direct response. 0.07. What is the difference between the highest and the lowest Value added (% of GDP) in Fragile and conflict affected situations?
Give a very brief answer. 10.65. What is the difference between the highest and the lowest Value added (% of GDP) in Upper middle income?
Make the answer very short. 1.35. What is the difference between the highest and the lowest Value added (% of GDP) in Argentina?
Keep it short and to the point. 6.61. What is the difference between the highest and the lowest Value added (% of GDP) of Austria?
Your response must be concise. 1.61. 